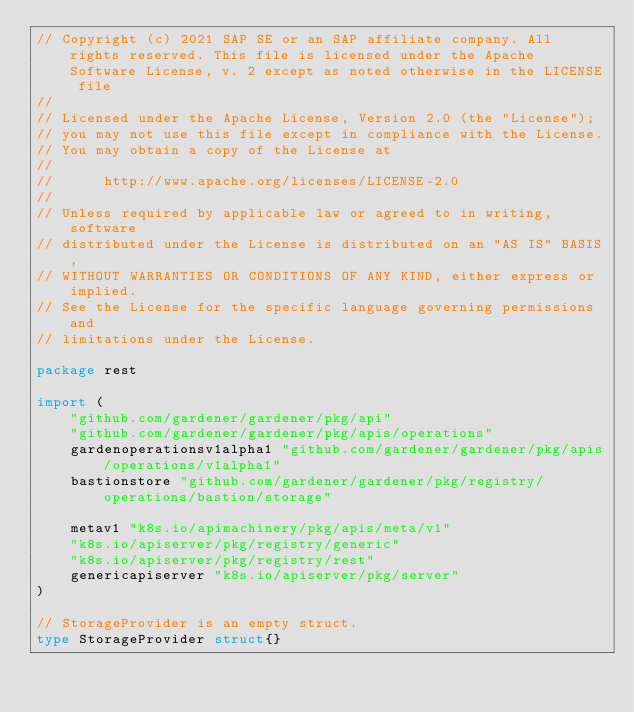<code> <loc_0><loc_0><loc_500><loc_500><_Go_>// Copyright (c) 2021 SAP SE or an SAP affiliate company. All rights reserved. This file is licensed under the Apache Software License, v. 2 except as noted otherwise in the LICENSE file
//
// Licensed under the Apache License, Version 2.0 (the "License");
// you may not use this file except in compliance with the License.
// You may obtain a copy of the License at
//
//      http://www.apache.org/licenses/LICENSE-2.0
//
// Unless required by applicable law or agreed to in writing, software
// distributed under the License is distributed on an "AS IS" BASIS,
// WITHOUT WARRANTIES OR CONDITIONS OF ANY KIND, either express or implied.
// See the License for the specific language governing permissions and
// limitations under the License.

package rest

import (
	"github.com/gardener/gardener/pkg/api"
	"github.com/gardener/gardener/pkg/apis/operations"
	gardenoperationsv1alpha1 "github.com/gardener/gardener/pkg/apis/operations/v1alpha1"
	bastionstore "github.com/gardener/gardener/pkg/registry/operations/bastion/storage"

	metav1 "k8s.io/apimachinery/pkg/apis/meta/v1"
	"k8s.io/apiserver/pkg/registry/generic"
	"k8s.io/apiserver/pkg/registry/rest"
	genericapiserver "k8s.io/apiserver/pkg/server"
)

// StorageProvider is an empty struct.
type StorageProvider struct{}
</code> 